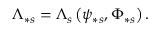Convert formula to latex. <formula><loc_0><loc_0><loc_500><loc_500>\Lambda _ { \ast s } = \Lambda _ { s } \left ( \psi _ { \ast s } , \Phi _ { \ast s } \right ) .</formula> 